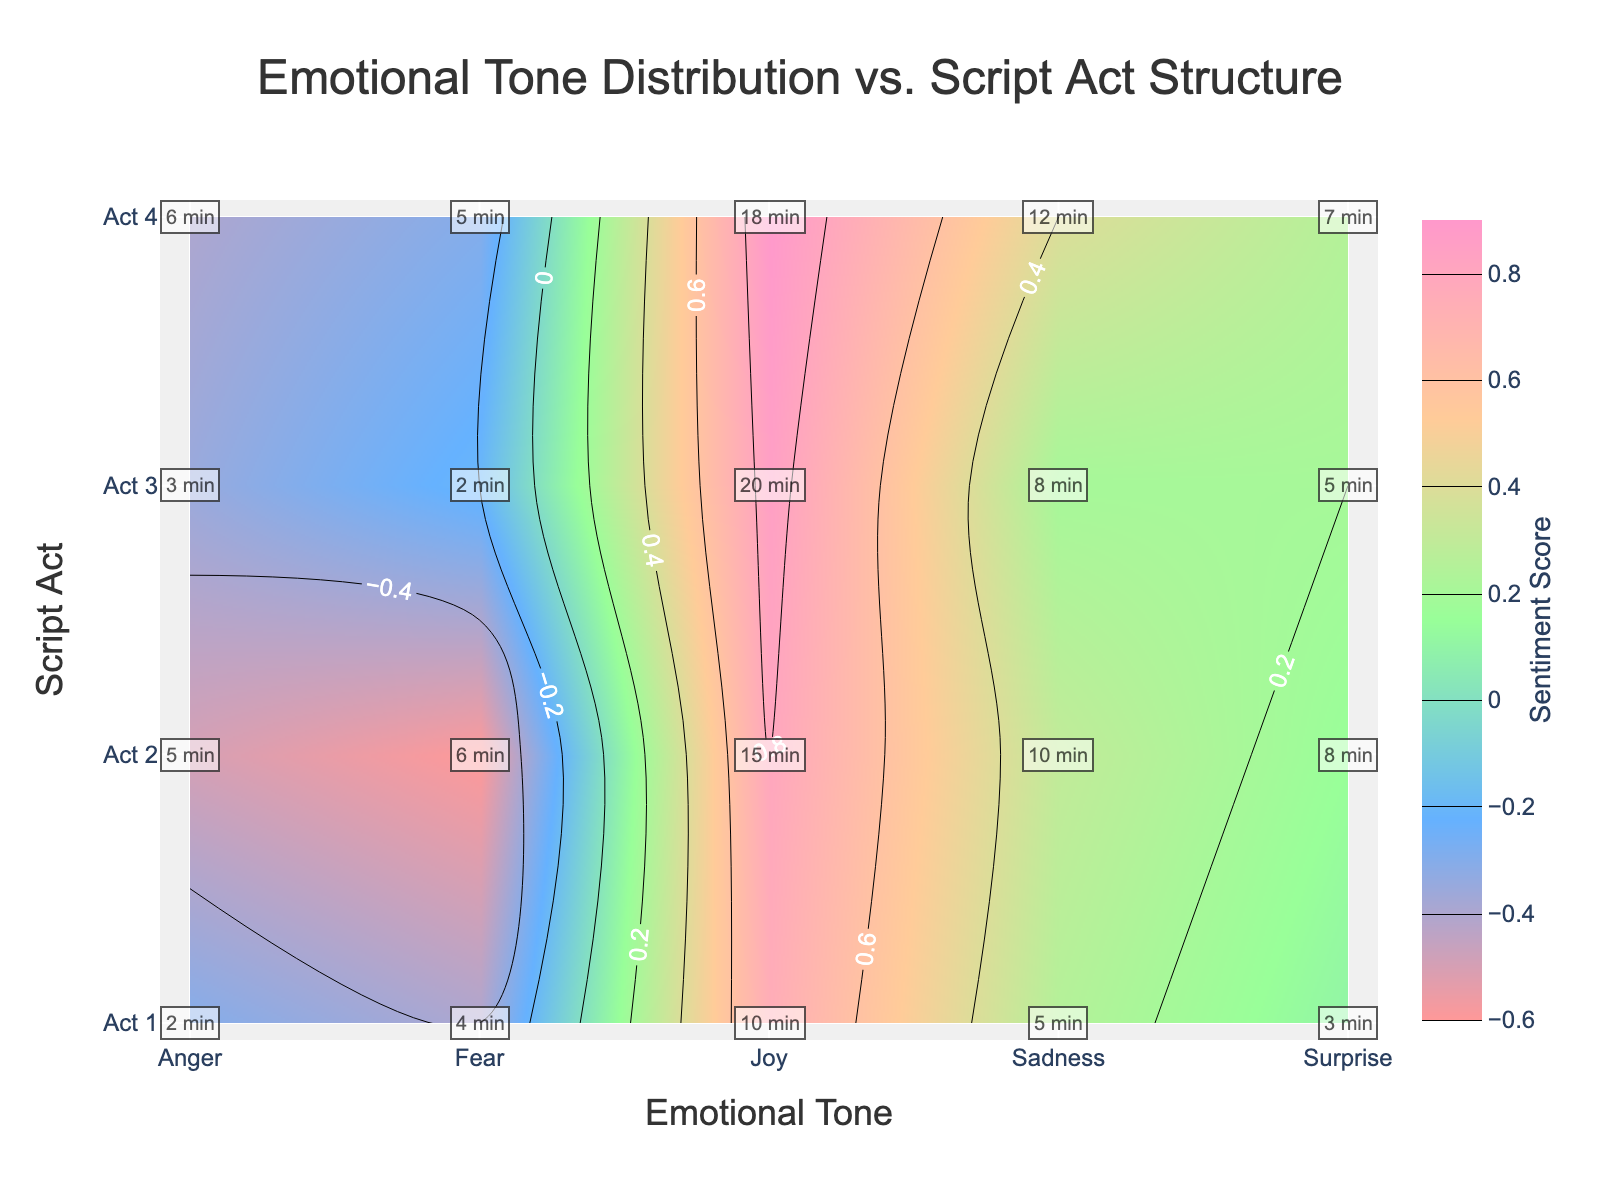What is the title of the figure? The title is usually displayed at the top of the figure. Here, it states "Emotional Tone Distribution vs. Script Act Structure."
Answer: Emotional Tone Distribution vs. Script Act Structure Which emotional tone has the highest sentiment score in Act 4? Look for the highest contour label in Act 4's row, which is for Joy with a sentiment score of 0.9.
Answer: Joy How much time is spent on 'Fear' in Act 2 compared to Act 4? From the annotations, we see 'Fear' in Act 2 is labeled as 6 minutes and in Act 4 as 5 minutes. Subtract the two to find the difference.
Answer: 1 minute more in Act 2 Which act has the lowest sentiment score for 'Anger'? Examine the contour labels for 'Anger' across all acts. The lowest sentiment score for 'Anger' is -0.5 in Act 2.
Answer: Act 2 What is the average sentiment score for 'Joy' across all acts? Add the sentiment scores for 'Joy' in all acts (0.75, 0.8, 0.85, 0.9) and divide by the number of acts (4). The calculation is (0.75 + 0.8 + 0.85 + 0.9) / 4 = 3.3 / 4 = 0.825.
Answer: 0.825 Which emotional tone has a consistently positive sentiment score across all acts? Check each tone's scores across acts. 'Joy' has consistently positive scores (0.75, 0.8, 0.85, 0.9).
Answer: Joy What is the total time spent on 'Sadness' throughout the script? Sum up the time annotations for 'Sadness' across all acts (5 + 10 + 8 + 12) = 35 minutes.
Answer: 35 minutes Which emotional tone has the highest variability in sentiment scores across the acts? Assess each tone’s range of sentiment scores by subtracting its lowest score from its highest. 'Anger's range is highest, varying from -0.6 to -0.2.
Answer: Anger How does 'Surprise' sentiment evolve from Act 1 to Act 4? Check the contour labels for 'Surprise' in each act: Act 1 (0.1), Act 2 (0.15), Act 3 (0.2), Act 4 (0.25). The sentiment scores consistently increase.
Answer: Increasing What is the difference in sentiment scores for 'Fear' between Act 1 and Act 4? Look at the scores for 'Fear' in Act 1 (-0.4) and Act 4 (-0.3). The difference is calculated as -0.3 - (-0.4) = 0.1.
Answer: 0.1 